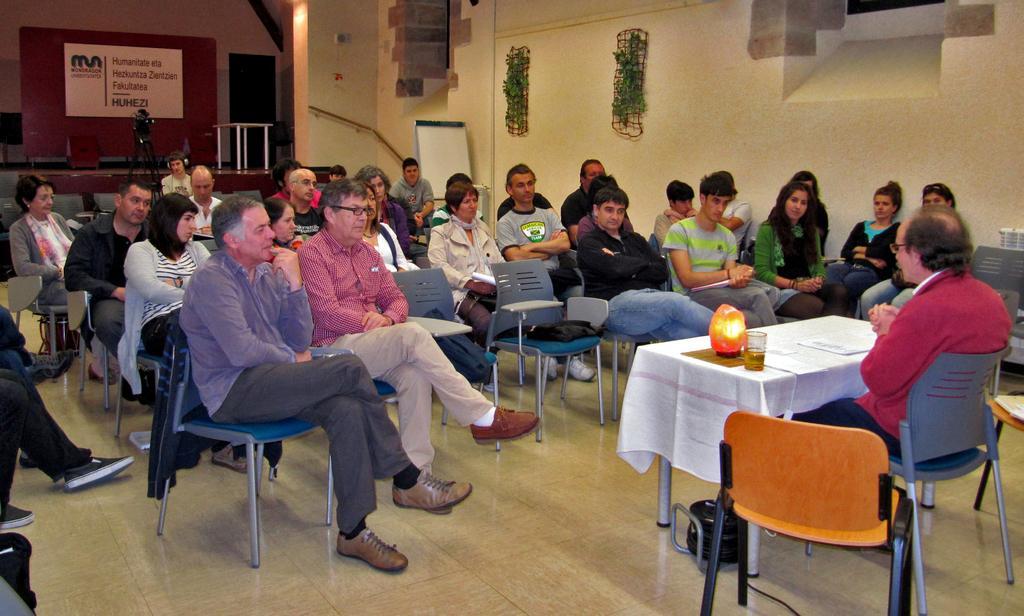Describe this image in one or two sentences. As we can see in the image there is a yellow color wall, banner, few people sitting on chairs and there is a table. On table there is a glass and papers. 